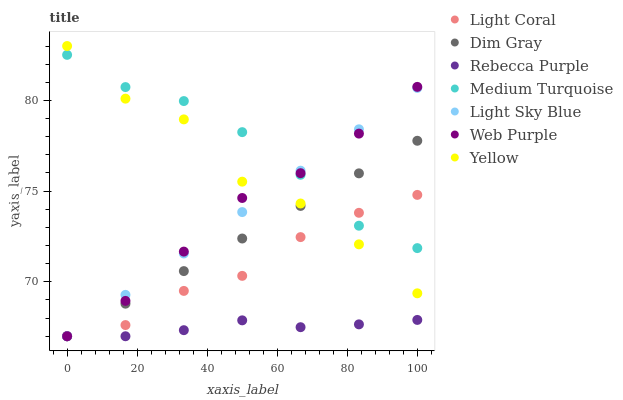Does Rebecca Purple have the minimum area under the curve?
Answer yes or no. Yes. Does Medium Turquoise have the maximum area under the curve?
Answer yes or no. Yes. Does Yellow have the minimum area under the curve?
Answer yes or no. No. Does Yellow have the maximum area under the curve?
Answer yes or no. No. Is Dim Gray the smoothest?
Answer yes or no. Yes. Is Yellow the roughest?
Answer yes or no. Yes. Is Light Coral the smoothest?
Answer yes or no. No. Is Light Coral the roughest?
Answer yes or no. No. Does Dim Gray have the lowest value?
Answer yes or no. Yes. Does Yellow have the lowest value?
Answer yes or no. No. Does Yellow have the highest value?
Answer yes or no. Yes. Does Light Coral have the highest value?
Answer yes or no. No. Is Rebecca Purple less than Yellow?
Answer yes or no. Yes. Is Medium Turquoise greater than Rebecca Purple?
Answer yes or no. Yes. Does Medium Turquoise intersect Web Purple?
Answer yes or no. Yes. Is Medium Turquoise less than Web Purple?
Answer yes or no. No. Is Medium Turquoise greater than Web Purple?
Answer yes or no. No. Does Rebecca Purple intersect Yellow?
Answer yes or no. No. 